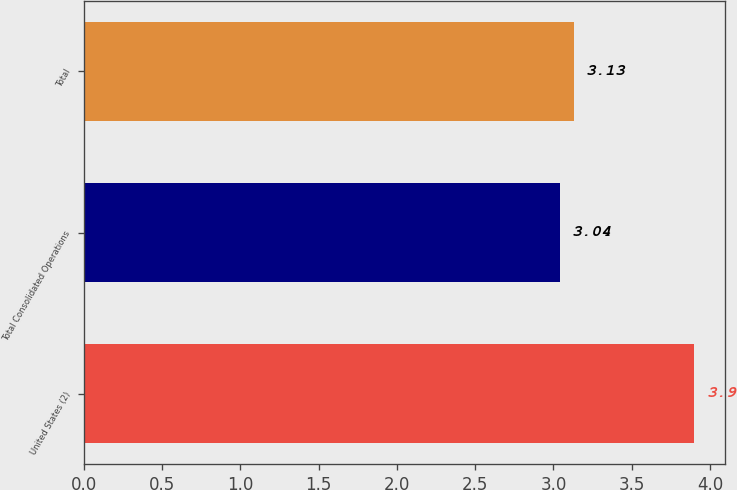Convert chart. <chart><loc_0><loc_0><loc_500><loc_500><bar_chart><fcel>United States (2)<fcel>Total Consolidated Operations<fcel>Total<nl><fcel>3.9<fcel>3.04<fcel>3.13<nl></chart> 